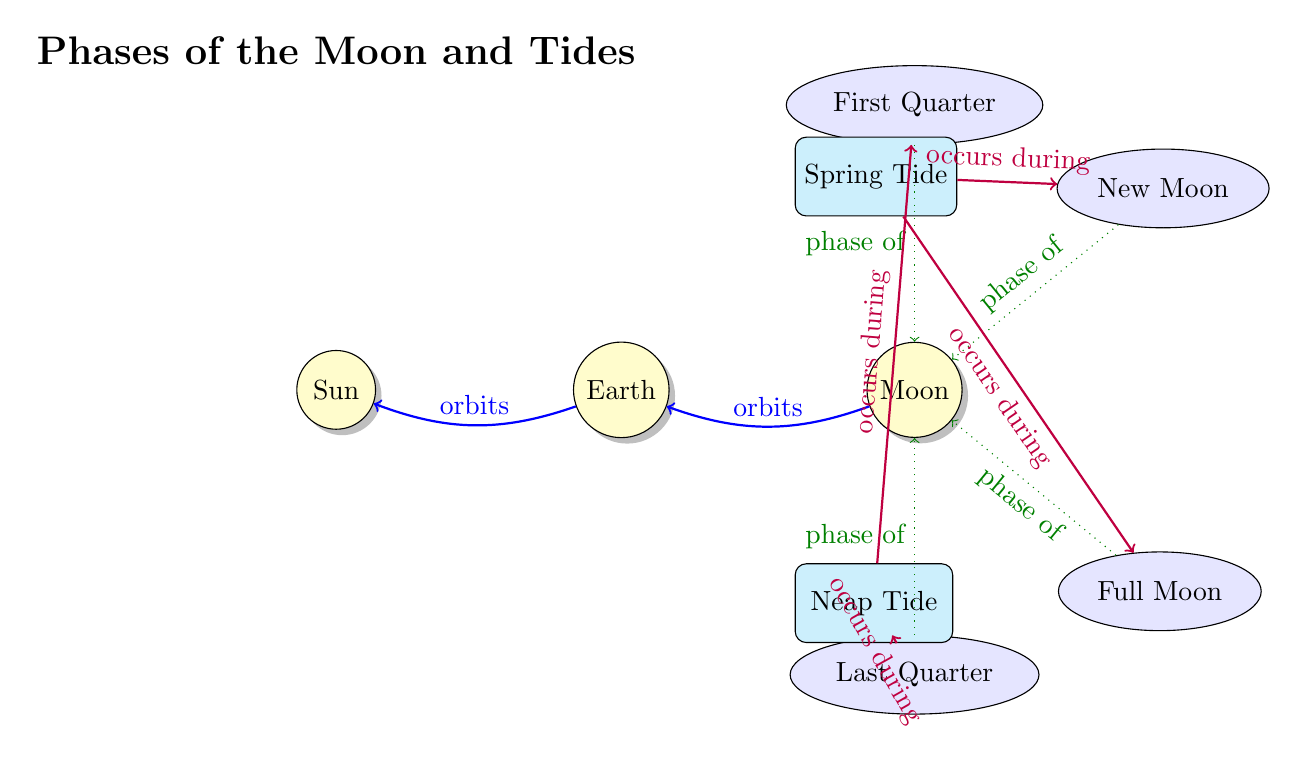What celestial bodies are represented in the diagram? The diagram includes three celestial bodies: the Sun, Earth, and Moon. This information can be directly observed from the labeled nodes in the diagram.
Answer: Sun, Earth, Moon How many phases of the Moon are shown? The diagram lists four distinct phases of the Moon: New Moon, Full Moon, First Quarter, and Last Quarter. These phases are clearly labeled and positioned around the Moon node.
Answer: Four Which tide occurs during the New Moon? According to the diagram, the Spring Tide occurs during the New Moon. The arrow points from the Spring Tide to the New Moon, indicating this relationship.
Answer: Spring Tide What shape represents the phases of the Moon? The phases of the Moon in the diagram are represented by ellipses. Each phase label is enclosed within an elliptical shape, which is specified in the diagram's style definitions.
Answer: Ellipse What type of tide occurs during both the New Moon and Full Moon? The diagram illustrates that the Spring Tide occurs during both the New Moon and Full Moon, as indicated by the arrows connecting these nodes.
Answer: Spring Tide What is the relationship between the First Quarter phase and the Neap Tide? The relationship is that the Neap Tide occurs during the First Quarter phase, as shown by the arrow connecting them in the diagram. This indicates that they are related in terms of timing.
Answer: Occurs during How many connections are there from the Moon phase nodes to the Moon? There are four connections from the Moon phase nodes (New Moon, Full Moon, First Quarter, Last Quarter) to the Moon node, indicating a direct relationship with each phase of the Moon.
Answer: Four Which celestial body does the Earth orbit? The diagram indicates that the Earth orbits around the Sun, which is indicated by the arrow labeled "orbits" connecting Earth and Sun nodes.
Answer: Sun 